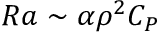Convert formula to latex. <formula><loc_0><loc_0><loc_500><loc_500>R a \sim \alpha \rho ^ { 2 } C _ { P }</formula> 